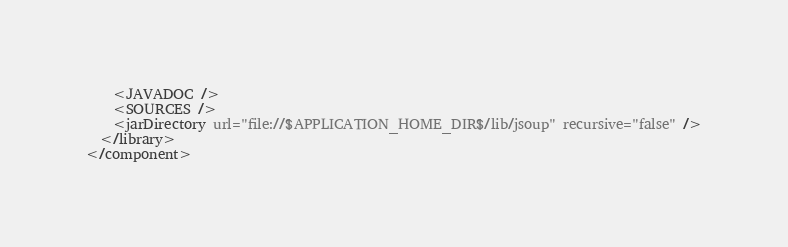Convert code to text. <code><loc_0><loc_0><loc_500><loc_500><_XML_>    <JAVADOC />
    <SOURCES />
    <jarDirectory url="file://$APPLICATION_HOME_DIR$/lib/jsoup" recursive="false" />
  </library>
</component></code> 